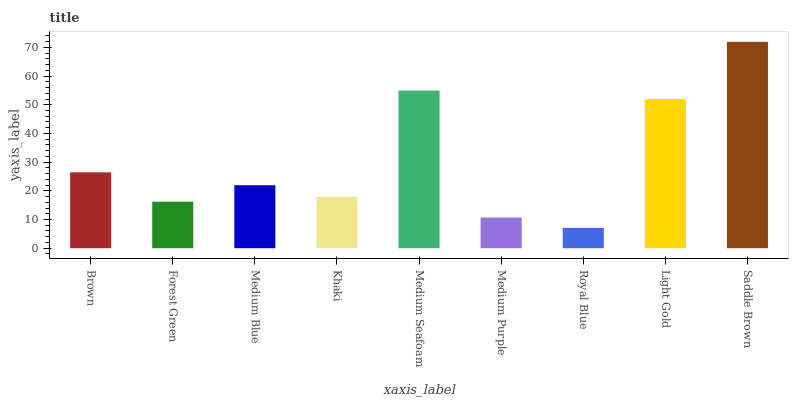Is Royal Blue the minimum?
Answer yes or no. Yes. Is Saddle Brown the maximum?
Answer yes or no. Yes. Is Forest Green the minimum?
Answer yes or no. No. Is Forest Green the maximum?
Answer yes or no. No. Is Brown greater than Forest Green?
Answer yes or no. Yes. Is Forest Green less than Brown?
Answer yes or no. Yes. Is Forest Green greater than Brown?
Answer yes or no. No. Is Brown less than Forest Green?
Answer yes or no. No. Is Medium Blue the high median?
Answer yes or no. Yes. Is Medium Blue the low median?
Answer yes or no. Yes. Is Forest Green the high median?
Answer yes or no. No. Is Medium Purple the low median?
Answer yes or no. No. 